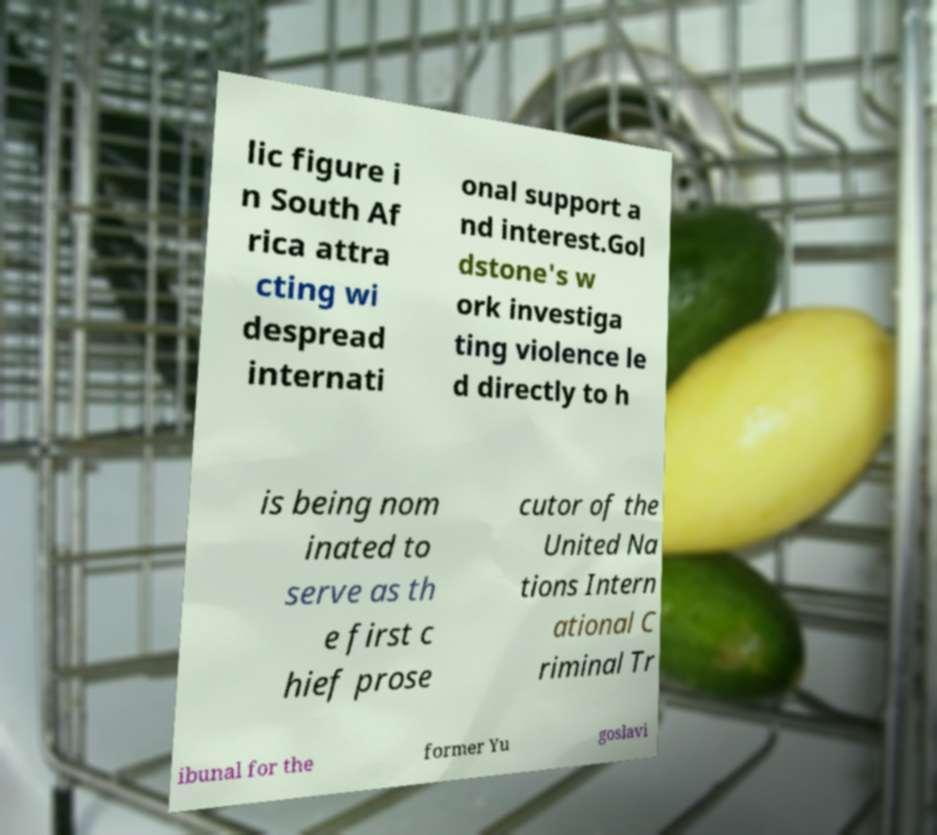Please read and relay the text visible in this image. What does it say? lic figure i n South Af rica attra cting wi despread internati onal support a nd interest.Gol dstone's w ork investiga ting violence le d directly to h is being nom inated to serve as th e first c hief prose cutor of the United Na tions Intern ational C riminal Tr ibunal for the former Yu goslavi 